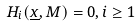<formula> <loc_0><loc_0><loc_500><loc_500>H _ { i } ( \underline { x } , M ) = 0 , i \geq 1</formula> 